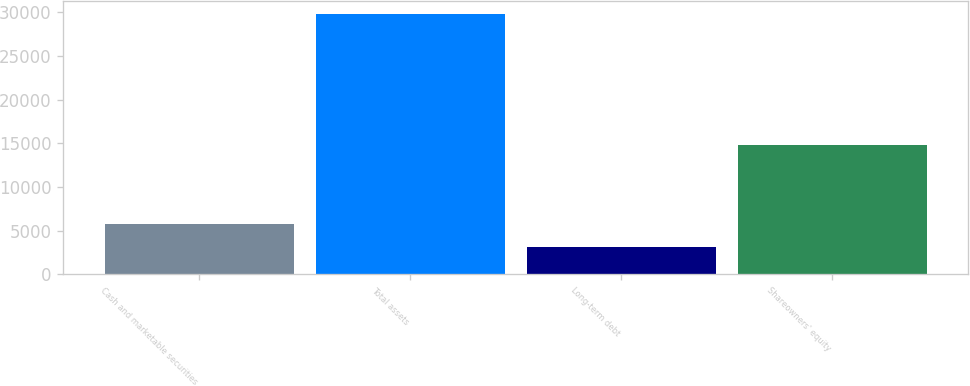<chart> <loc_0><loc_0><loc_500><loc_500><bar_chart><fcel>Cash and marketable securities<fcel>Total assets<fcel>Long-term debt<fcel>Shareowners' equity<nl><fcel>5807.5<fcel>29734<fcel>3149<fcel>14852<nl></chart> 